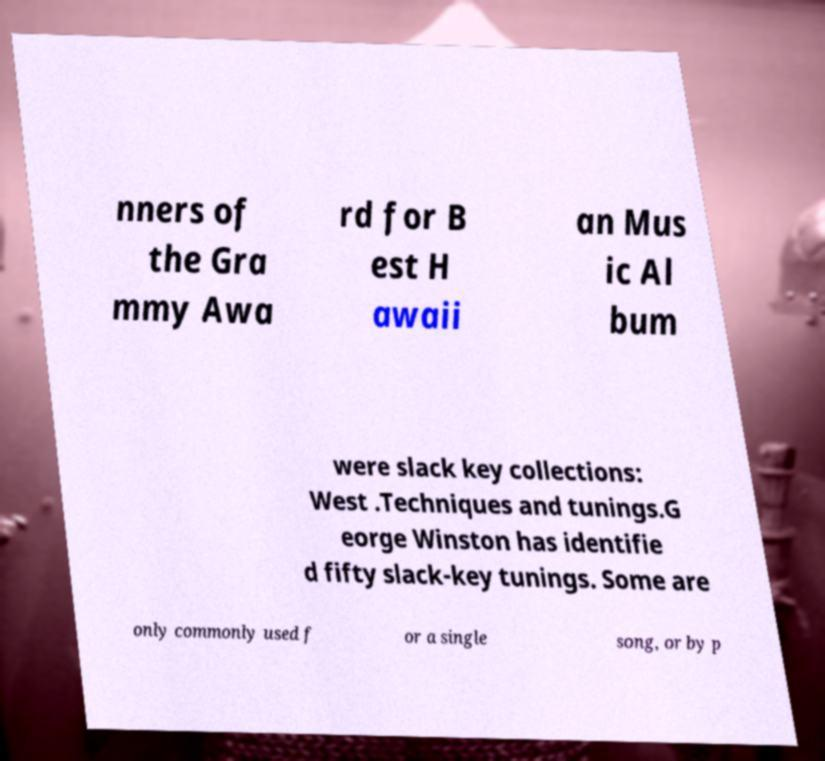For documentation purposes, I need the text within this image transcribed. Could you provide that? nners of the Gra mmy Awa rd for B est H awaii an Mus ic Al bum were slack key collections: West .Techniques and tunings.G eorge Winston has identifie d fifty slack-key tunings. Some are only commonly used f or a single song, or by p 